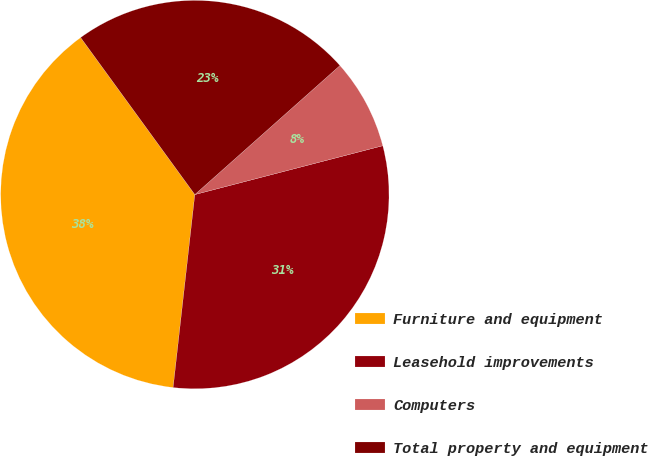Convert chart. <chart><loc_0><loc_0><loc_500><loc_500><pie_chart><fcel>Furniture and equipment<fcel>Leasehold improvements<fcel>Computers<fcel>Total property and equipment<nl><fcel>38.21%<fcel>30.83%<fcel>7.52%<fcel>23.44%<nl></chart> 